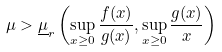<formula> <loc_0><loc_0><loc_500><loc_500>\mu > \underline { \mu } _ { r } \left ( \sup _ { x \geq 0 } \frac { f ( x ) } { g ( x ) } , \sup _ { x \geq 0 } \frac { g ( x ) } { x } \right )</formula> 